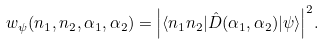Convert formula to latex. <formula><loc_0><loc_0><loc_500><loc_500>w _ { \psi } ( n _ { 1 } , n _ { 2 } , \alpha _ { 1 } , \alpha _ { 2 } ) = { \left | \langle n _ { 1 } n _ { 2 } | { \hat { D } } ( \alpha _ { 1 } , \alpha _ { 2 } ) | \psi \rangle \right | } ^ { 2 } .</formula> 